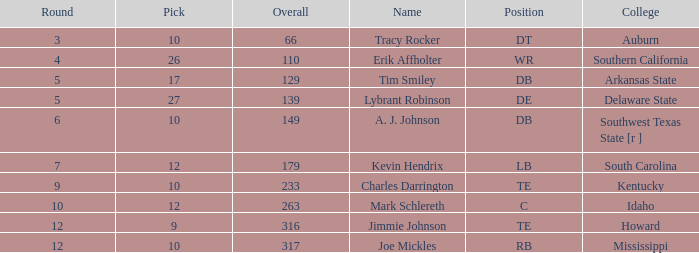Would you be able to parse every entry in this table? {'header': ['Round', 'Pick', 'Overall', 'Name', 'Position', 'College'], 'rows': [['3', '10', '66', 'Tracy Rocker', 'DT', 'Auburn'], ['4', '26', '110', 'Erik Affholter', 'WR', 'Southern California'], ['5', '17', '129', 'Tim Smiley', 'DB', 'Arkansas State'], ['5', '27', '139', 'Lybrant Robinson', 'DE', 'Delaware State'], ['6', '10', '149', 'A. J. Johnson', 'DB', 'Southwest Texas State [r ]'], ['7', '12', '179', 'Kevin Hendrix', 'LB', 'South Carolina'], ['9', '10', '233', 'Charles Darrington', 'TE', 'Kentucky'], ['10', '12', '263', 'Mark Schlereth', 'C', 'Idaho'], ['12', '9', '316', 'Jimmie Johnson', 'TE', 'Howard'], ['12', '10', '317', 'Joe Mickles', 'RB', 'Mississippi']]} For "tim smiley", what is the combined value of overall in rounds fewer than 5? None. 